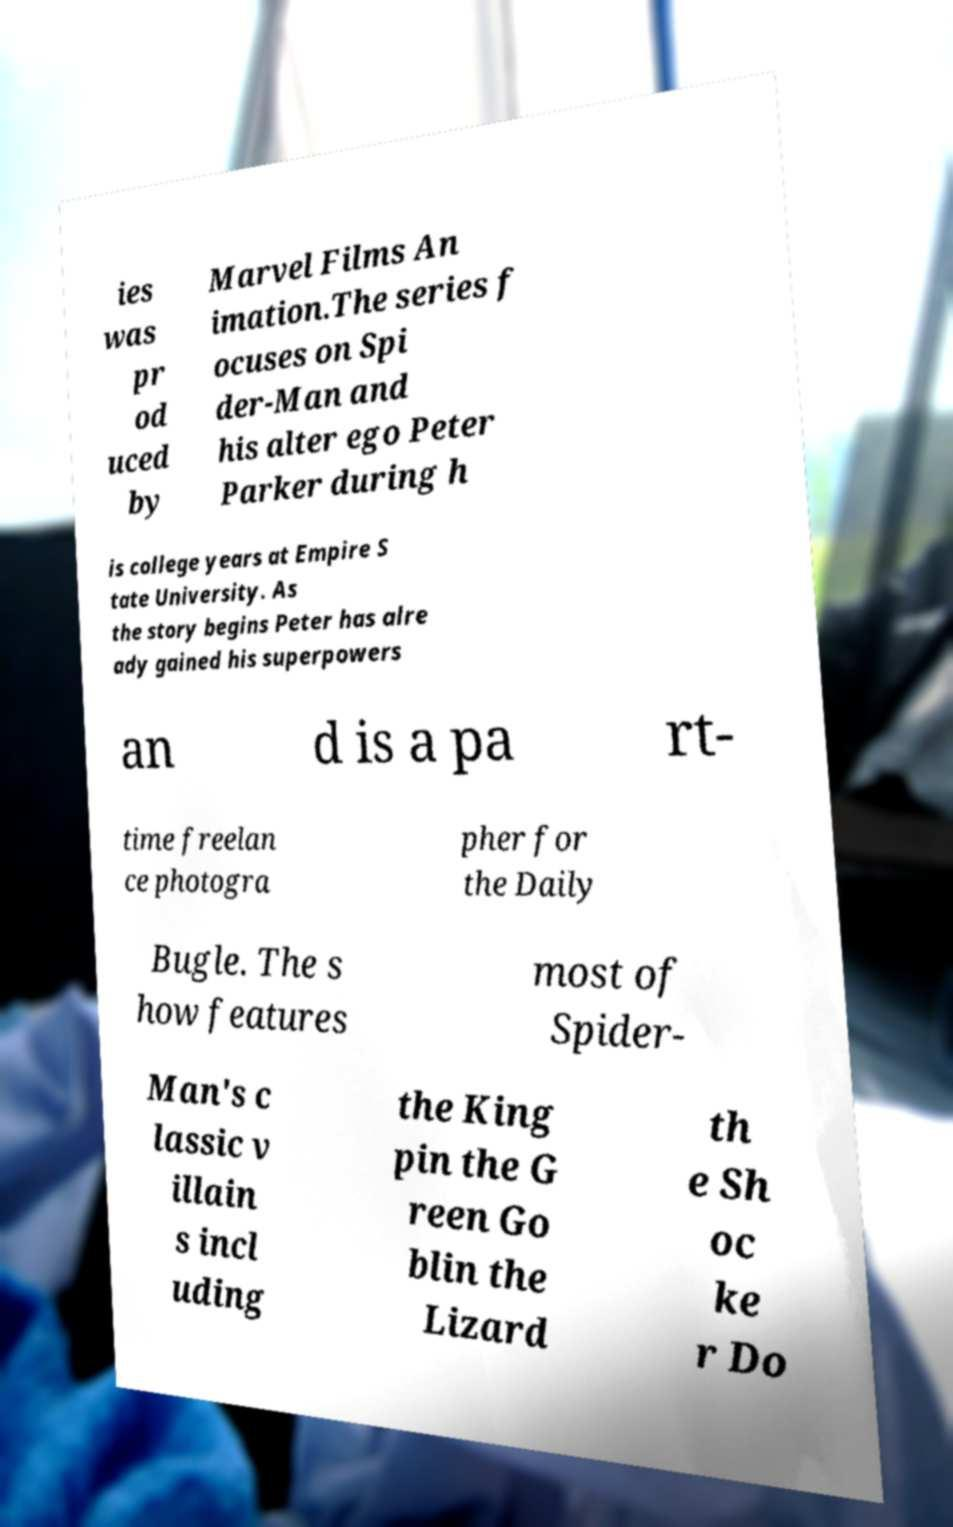Can you read and provide the text displayed in the image?This photo seems to have some interesting text. Can you extract and type it out for me? ies was pr od uced by Marvel Films An imation.The series f ocuses on Spi der-Man and his alter ego Peter Parker during h is college years at Empire S tate University. As the story begins Peter has alre ady gained his superpowers an d is a pa rt- time freelan ce photogra pher for the Daily Bugle. The s how features most of Spider- Man's c lassic v illain s incl uding the King pin the G reen Go blin the Lizard th e Sh oc ke r Do 